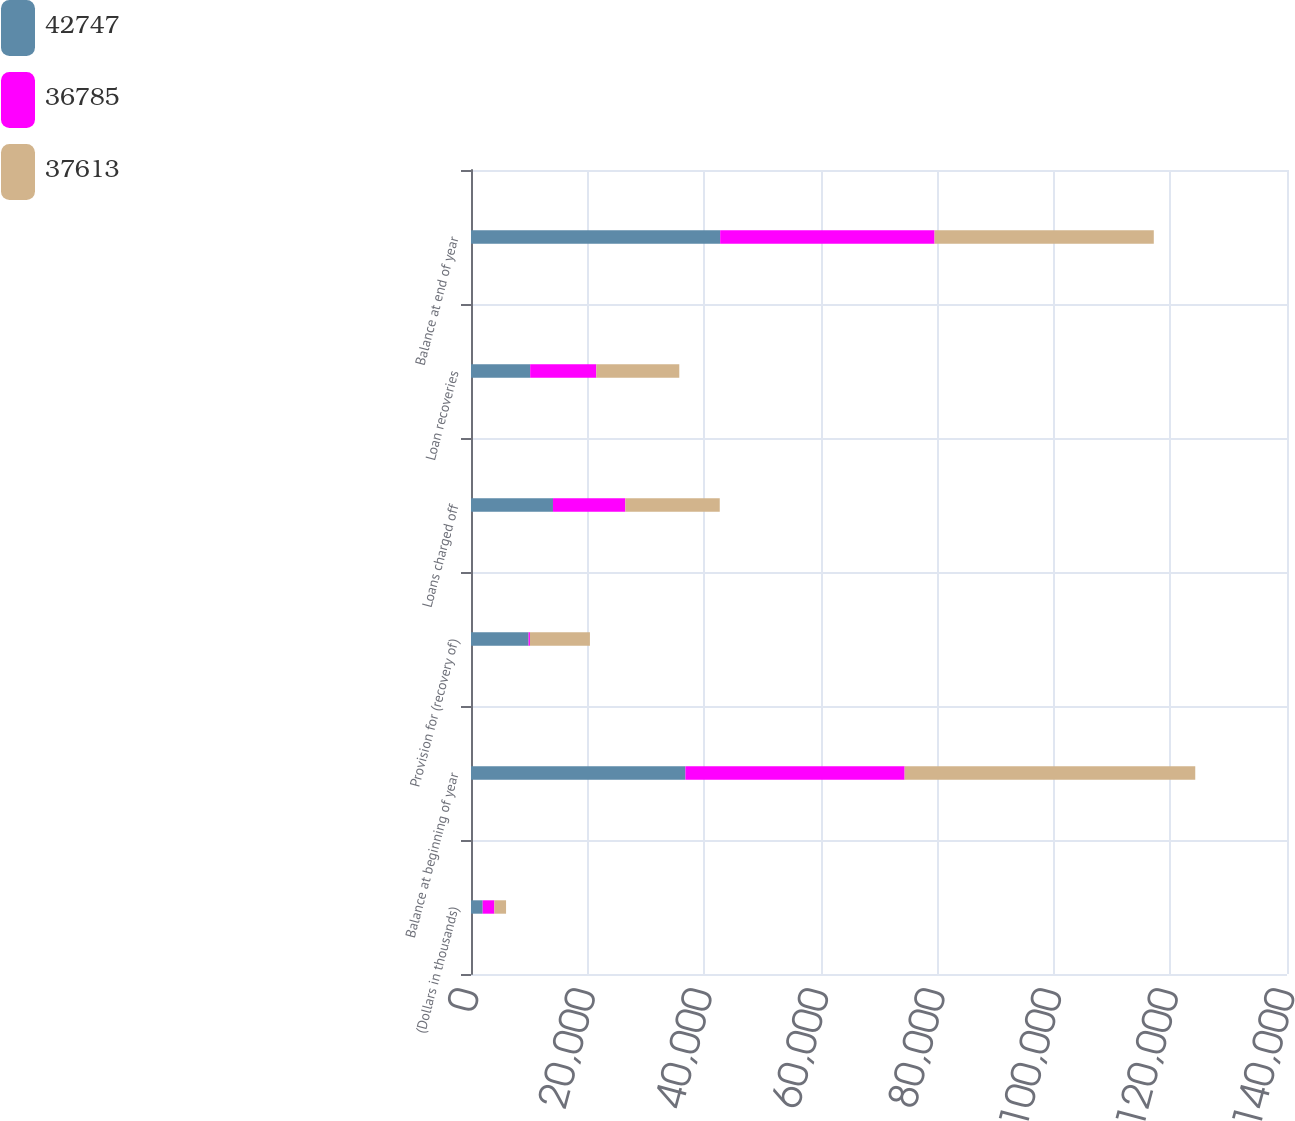Convert chart. <chart><loc_0><loc_0><loc_500><loc_500><stacked_bar_chart><ecel><fcel>(Dollars in thousands)<fcel>Balance at beginning of year<fcel>Provision for (recovery of)<fcel>Loans charged off<fcel>Loan recoveries<fcel>Balance at end of year<nl><fcel>42747<fcel>2006<fcel>36785<fcel>9877<fcel>14065<fcel>10150<fcel>42747<nl><fcel>36785<fcel>2005<fcel>37613<fcel>237<fcel>12416<fcel>11351<fcel>36785<nl><fcel>37613<fcel>2004<fcel>49862<fcel>10289<fcel>16196<fcel>14236<fcel>37613<nl></chart> 